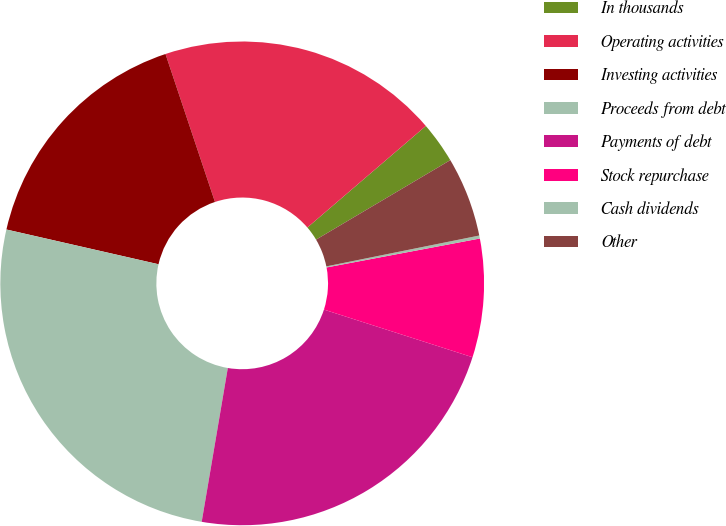Convert chart to OTSL. <chart><loc_0><loc_0><loc_500><loc_500><pie_chart><fcel>In thousands<fcel>Operating activities<fcel>Investing activities<fcel>Proceeds from debt<fcel>Payments of debt<fcel>Stock repurchase<fcel>Cash dividends<fcel>Other<nl><fcel>2.77%<fcel>18.86%<fcel>16.29%<fcel>25.9%<fcel>22.74%<fcel>7.91%<fcel>0.2%<fcel>5.34%<nl></chart> 